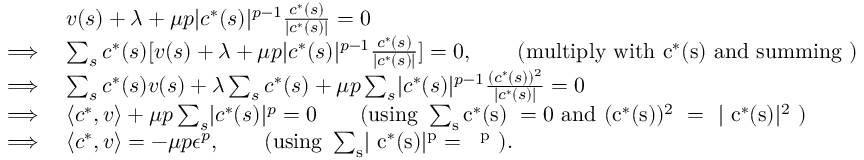Convert formula to latex. <formula><loc_0><loc_0><loc_500><loc_500>\begin{array} { r l } & { v ( s ) + \lambda + \mu p | c ^ { * } ( s ) | ^ { p - 1 } \frac { c ^ { * } ( s ) } { | c ^ { * } ( s ) | } = 0 } \\ { \implies } & { \sum _ { s } c ^ { * } ( s ) [ v ( s ) + \lambda + \mu p | c ^ { * } ( s ) | ^ { p - 1 } \frac { c ^ { * } ( s ) } { | c ^ { * } ( s ) | } ] = 0 , \quad ( m u l t i p l y w i t h c ^ { * } ( s ) a n d s u m \min g ) } \\ { \implies } & { \sum _ { s } c ^ { * } ( s ) v ( s ) + \lambda \sum _ { s } c ^ { * } ( s ) + \mu p \sum _ { s } | c ^ { * } ( s ) | ^ { p - 1 } \frac { ( c ^ { * } ( s ) ) ^ { 2 } } { | c ^ { * } ( s ) | } = 0 } \\ { \implies } & { \langle c ^ { * } , v \rangle + \mu p \sum _ { s } | c ^ { * } ( s ) | ^ { p } = 0 \quad ( u \sin g \sum _ { s } c ^ { * } ( s ) = 0 a n d ( c ^ { * } ( s ) ) ^ { 2 } = | c ^ { * } ( s ) | ^ { 2 } ) } \\ { \implies } & { \langle c ^ { * } , v \rangle = - \mu p \epsilon ^ { p } , \quad ( u \sin g \sum _ { s } | c ^ { * } ( s ) | ^ { p } = \epsilon ^ { p } ) . } \end{array}</formula> 